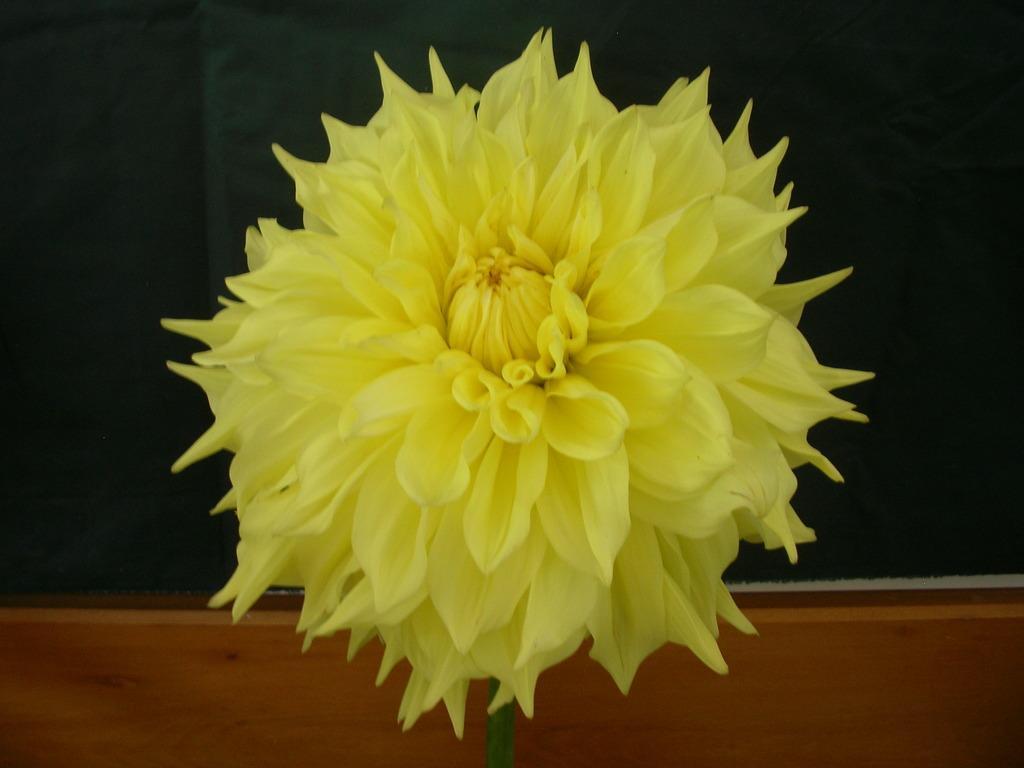Please provide a concise description of this image. In this picture there is yellow color flower in the image. 